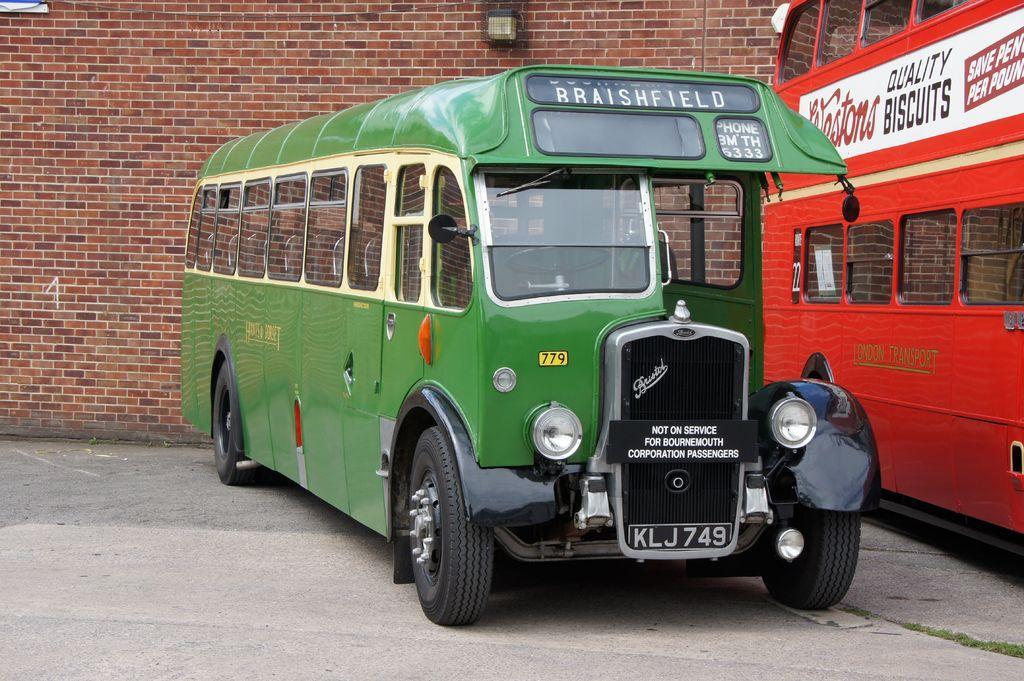Could you give a brief overview of what you see in this image? In this image there are two vehicles parked, behind the vehicles there is a wall with red bricks and an object is hanging. 